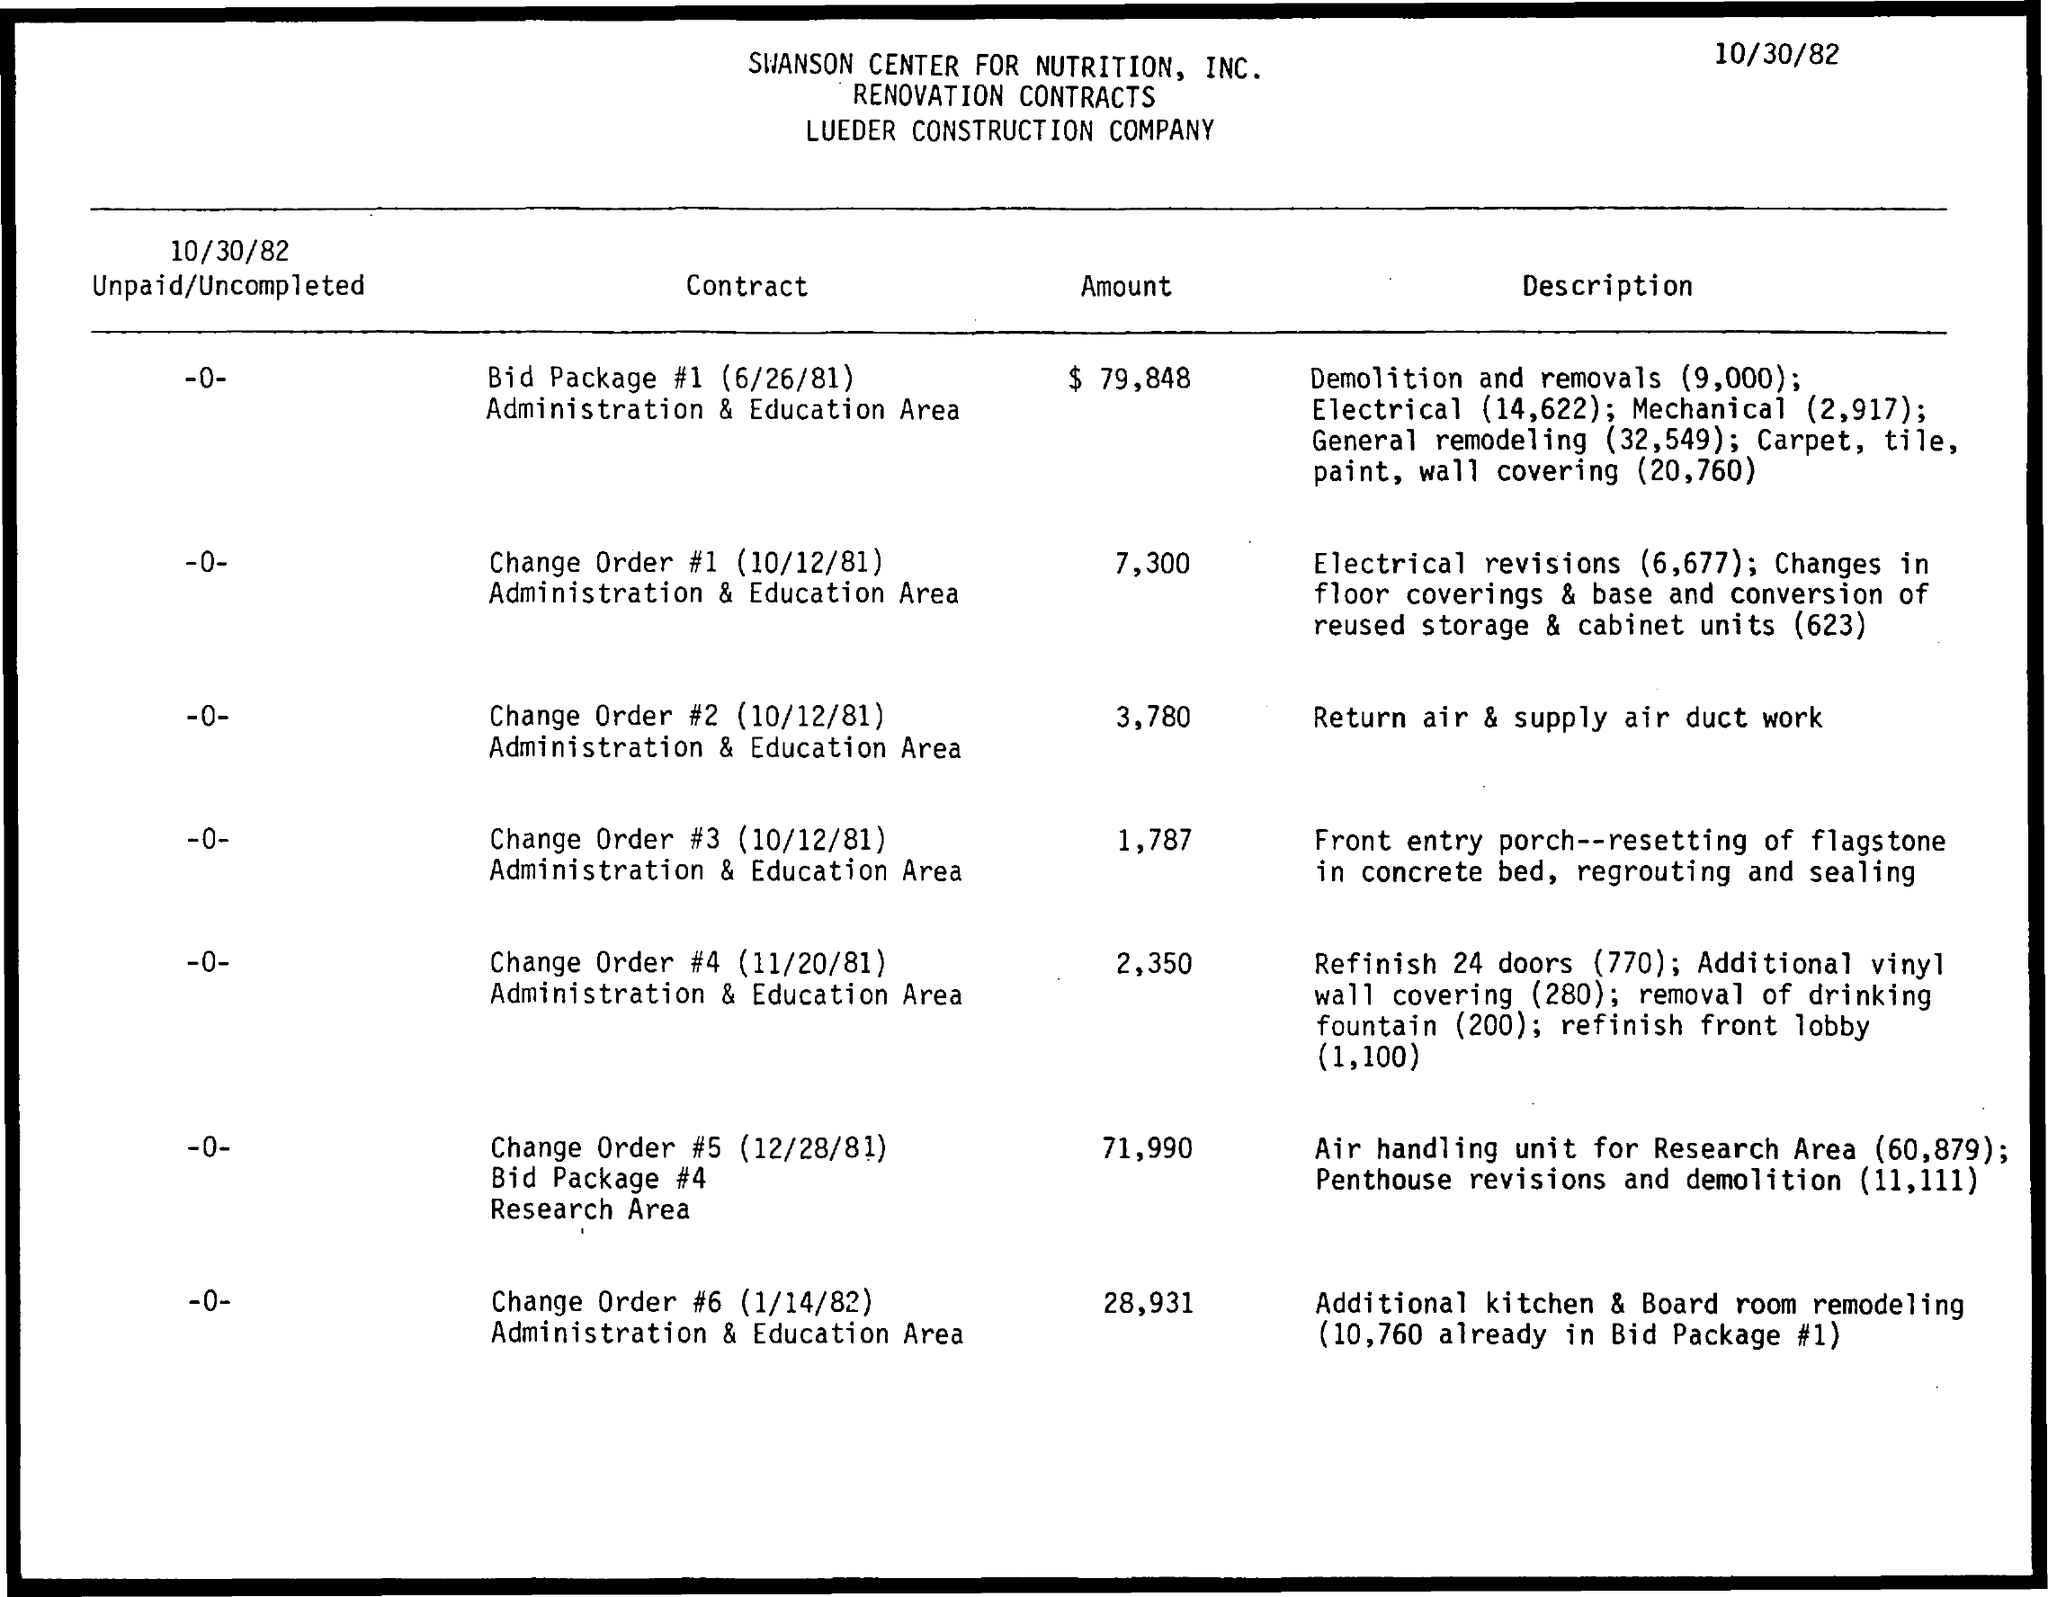Give some essential details in this illustration. The date on the document is October 30, 1982. The amount for Change Order #5 (12/28/81) Bid package #4 Research Area is $71,990. 